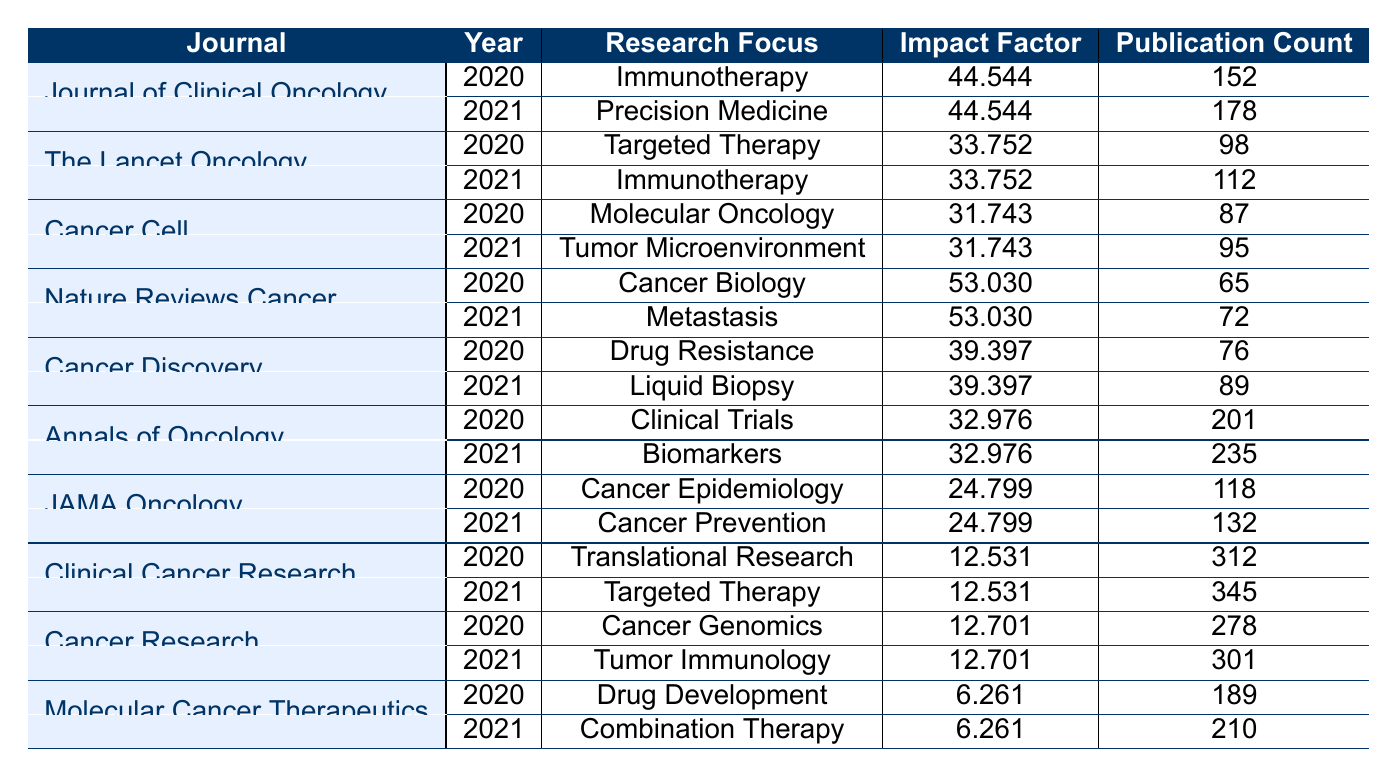What is the highest impact factor recorded in this table? Scanning the impact factors listed, I find that the highest value is associated with "Nature Reviews Cancer" at 53.03.
Answer: 53.03 Which journal published the most articles in 2021? By reviewing the publication counts for 2021, "Clinical Cancer Research" has the highest count of 345 publications.
Answer: Clinical Cancer Research How many publications did "Annals of Oncology" have in total across 2020 and 2021? Summing the publication counts: 201 (2020) + 235 (2021) = 436.
Answer: 436 Did "Cancer Cell" focus on the same research topic in both years? In 2020, "Cancer Cell" published on "Molecular Oncology," and in 2021, it focused on "Tumor Microenvironment," indicating a change in research focus.
Answer: No What was the increase in publication count for "Journal of Clinical Oncology" from 2020 to 2021? The publication count increased from 152 in 2020 to 178 in 2021. The increase is 178 - 152 = 26.
Answer: 26 Which research focus had the highest publication count in 2020? The highest count in 2020 is from "Clinical Cancer Research" with 312 publications.
Answer: Translational Research Is the impact factor of "Cancer Discovery" the same for both years? The impact factor of "Cancer Discovery" is consistent at 39.397 for both 2020 and 2021.
Answer: Yes What is the average publication count across all journals in 2021? Calculating the total publications in 2021: 178 + 112 + 95 + 72 + 89 + 235 + 132 + 345 + 301 + 210 gives 1374 total publications. Dividing by the count of journals (10), the average is 1374 / 10 = 137.4.
Answer: 137.4 